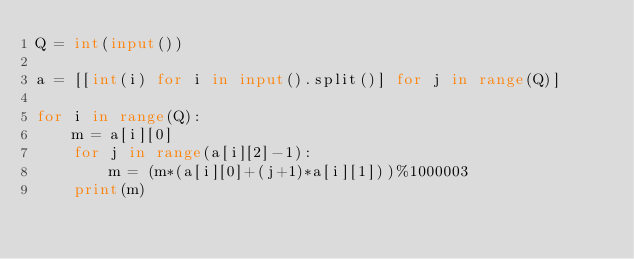<code> <loc_0><loc_0><loc_500><loc_500><_Python_>Q = int(input())

a = [[int(i) for i in input().split()] for j in range(Q)]

for i in range(Q):
    m = a[i][0]
    for j in range(a[i][2]-1):
        m = (m*(a[i][0]+(j+1)*a[i][1]))%1000003
    print(m)</code> 